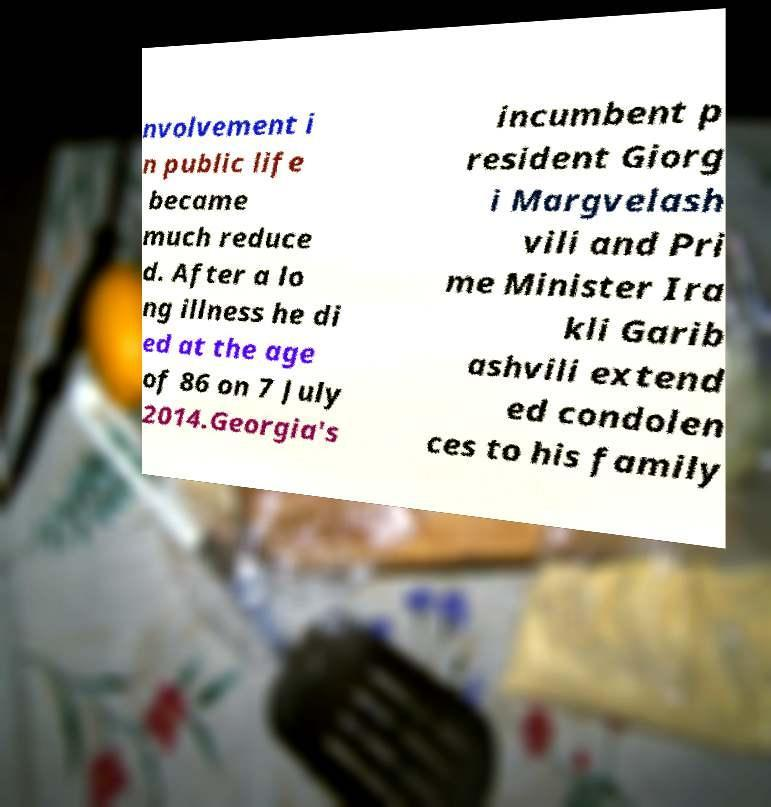Could you assist in decoding the text presented in this image and type it out clearly? nvolvement i n public life became much reduce d. After a lo ng illness he di ed at the age of 86 on 7 July 2014.Georgia's incumbent p resident Giorg i Margvelash vili and Pri me Minister Ira kli Garib ashvili extend ed condolen ces to his family 